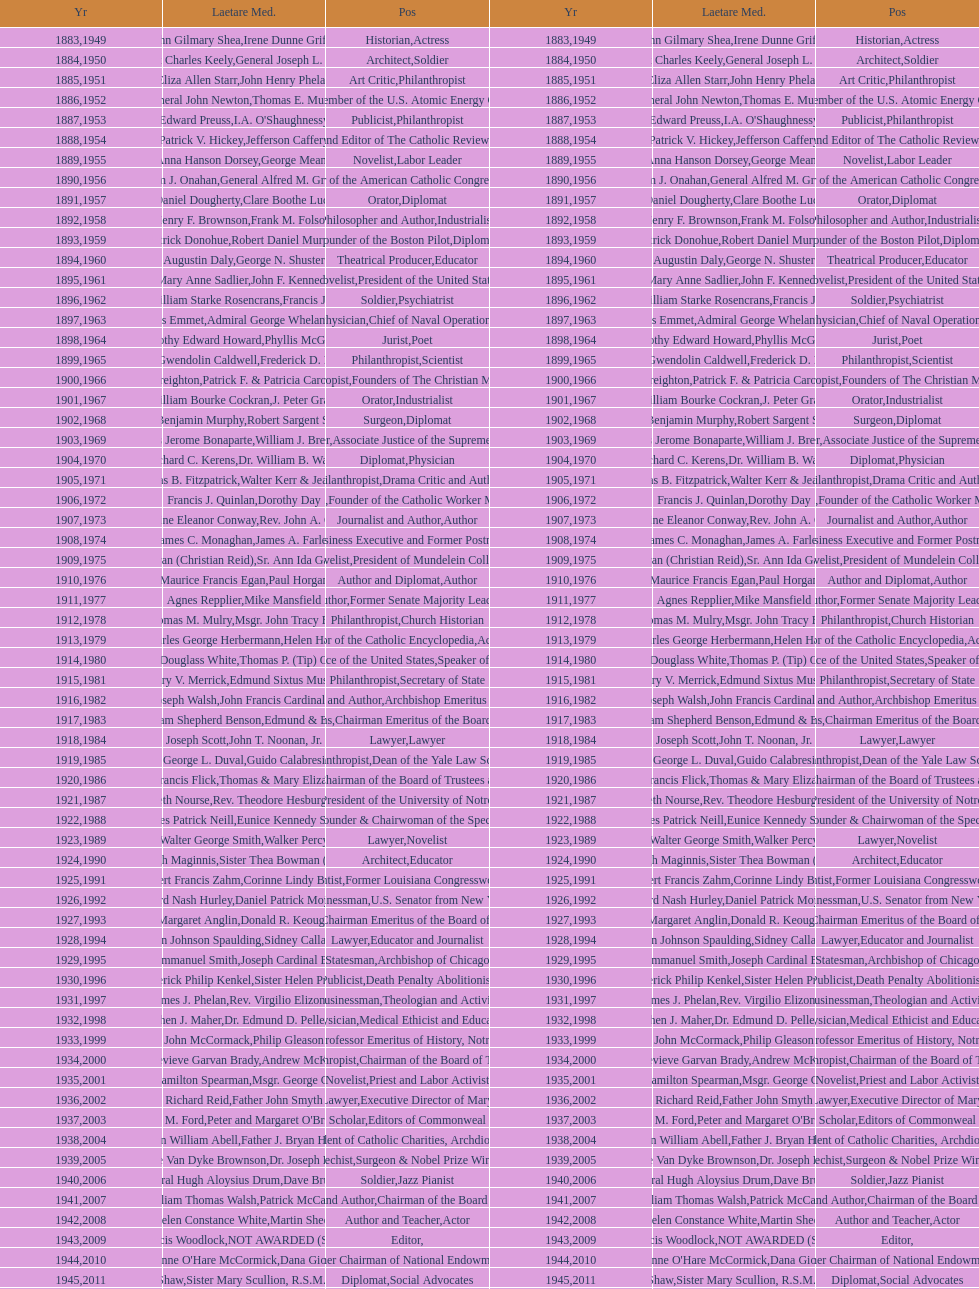What are the total number of times soldier is listed as the position on this chart? 4. 